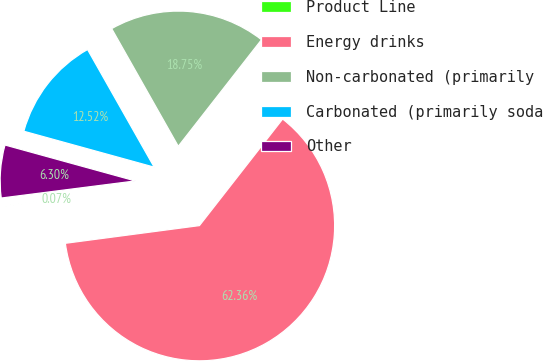<chart> <loc_0><loc_0><loc_500><loc_500><pie_chart><fcel>Product Line<fcel>Energy drinks<fcel>Non-carbonated (primarily<fcel>Carbonated (primarily soda<fcel>Other<nl><fcel>0.07%<fcel>62.36%<fcel>18.75%<fcel>12.52%<fcel>6.3%<nl></chart> 